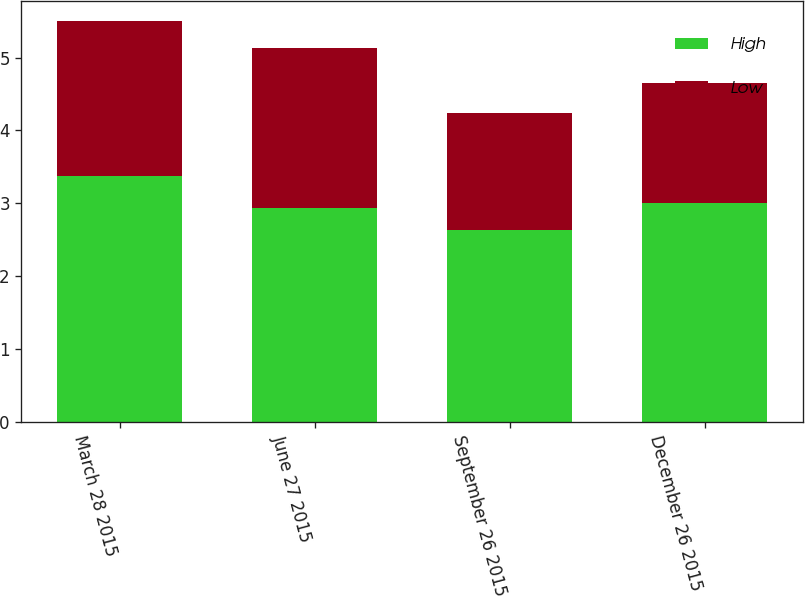<chart> <loc_0><loc_0><loc_500><loc_500><stacked_bar_chart><ecel><fcel>March 28 2015<fcel>June 27 2015<fcel>September 26 2015<fcel>December 26 2015<nl><fcel>High<fcel>3.37<fcel>2.94<fcel>2.63<fcel>3<nl><fcel>Low<fcel>2.14<fcel>2.2<fcel>1.61<fcel>1.65<nl></chart> 